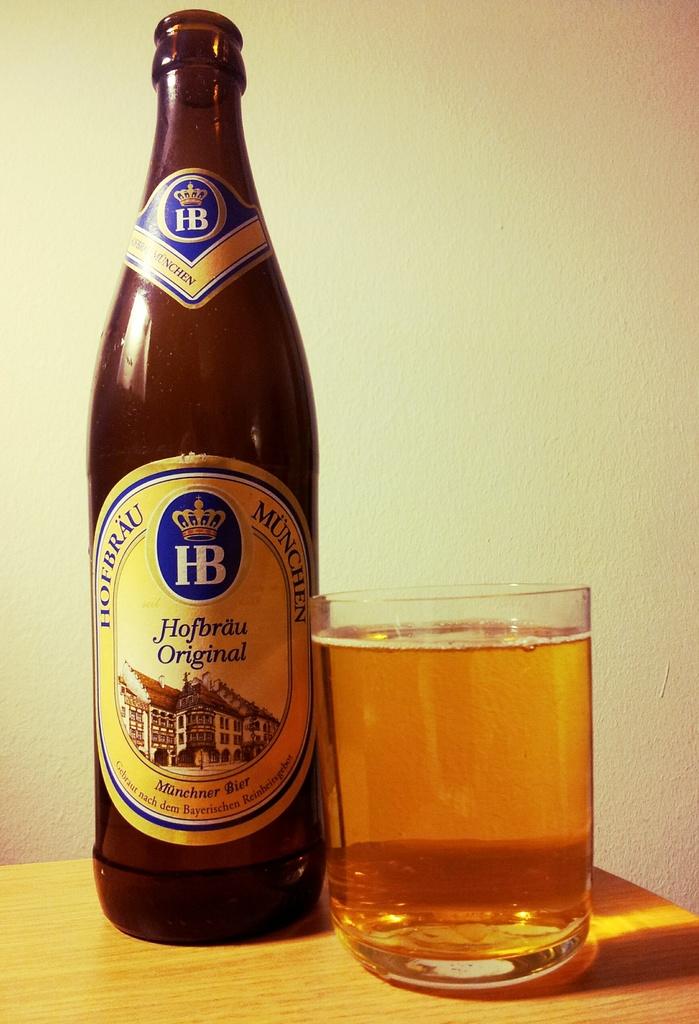What brand of beer is on the table?
Your answer should be compact. Hofbrau. 